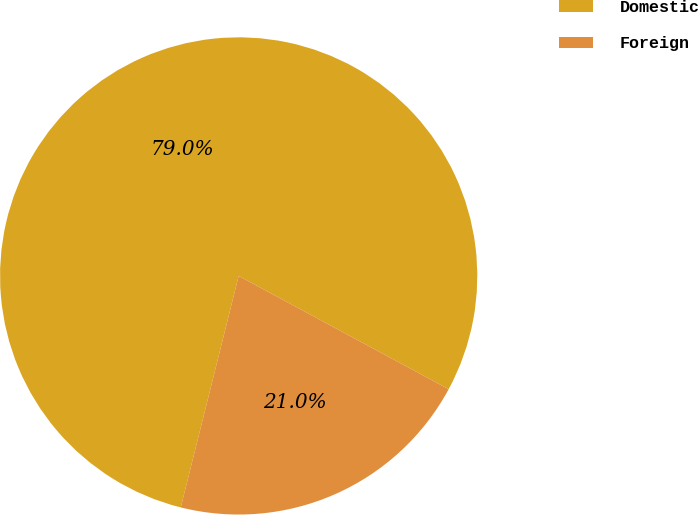Convert chart. <chart><loc_0><loc_0><loc_500><loc_500><pie_chart><fcel>Domestic<fcel>Foreign<nl><fcel>78.97%<fcel>21.03%<nl></chart> 